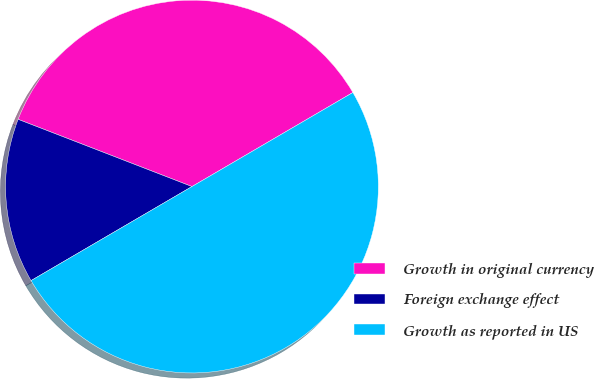Convert chart. <chart><loc_0><loc_0><loc_500><loc_500><pie_chart><fcel>Growth in original currency<fcel>Foreign exchange effect<fcel>Growth as reported in US<nl><fcel>35.71%<fcel>14.29%<fcel>50.0%<nl></chart> 